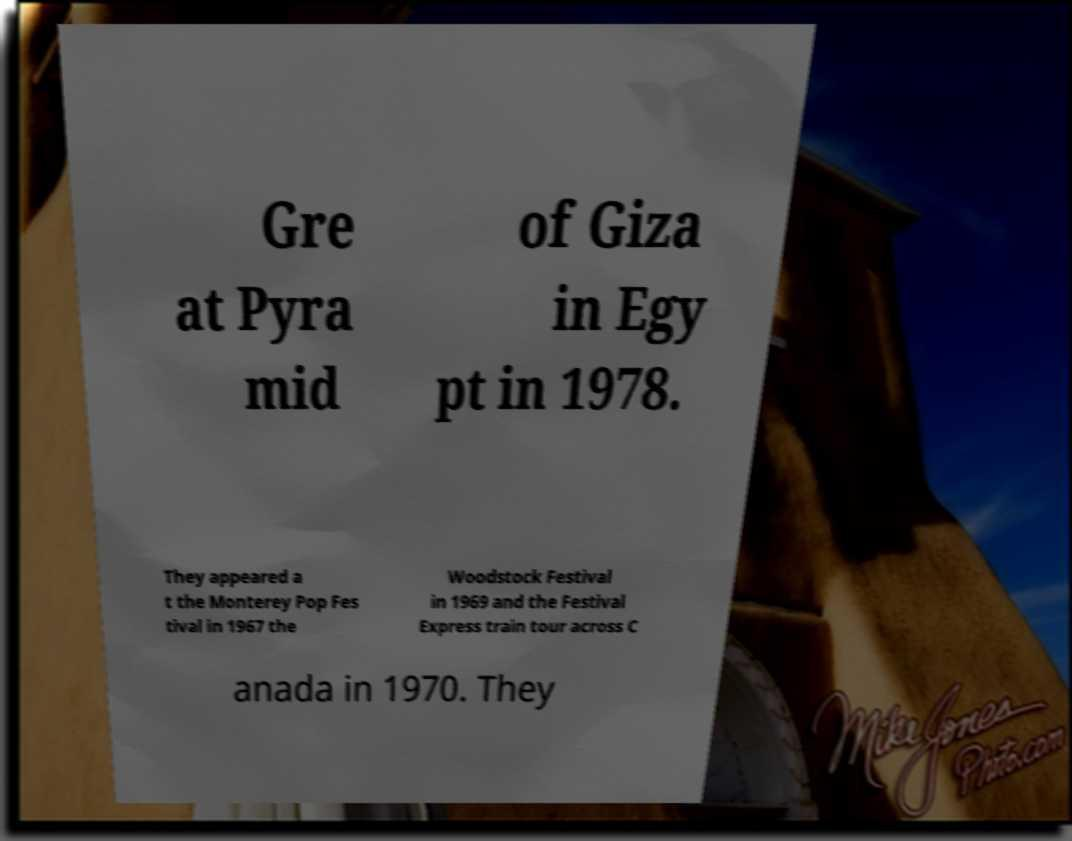Please read and relay the text visible in this image. What does it say? Gre at Pyra mid of Giza in Egy pt in 1978. They appeared a t the Monterey Pop Fes tival in 1967 the Woodstock Festival in 1969 and the Festival Express train tour across C anada in 1970. They 